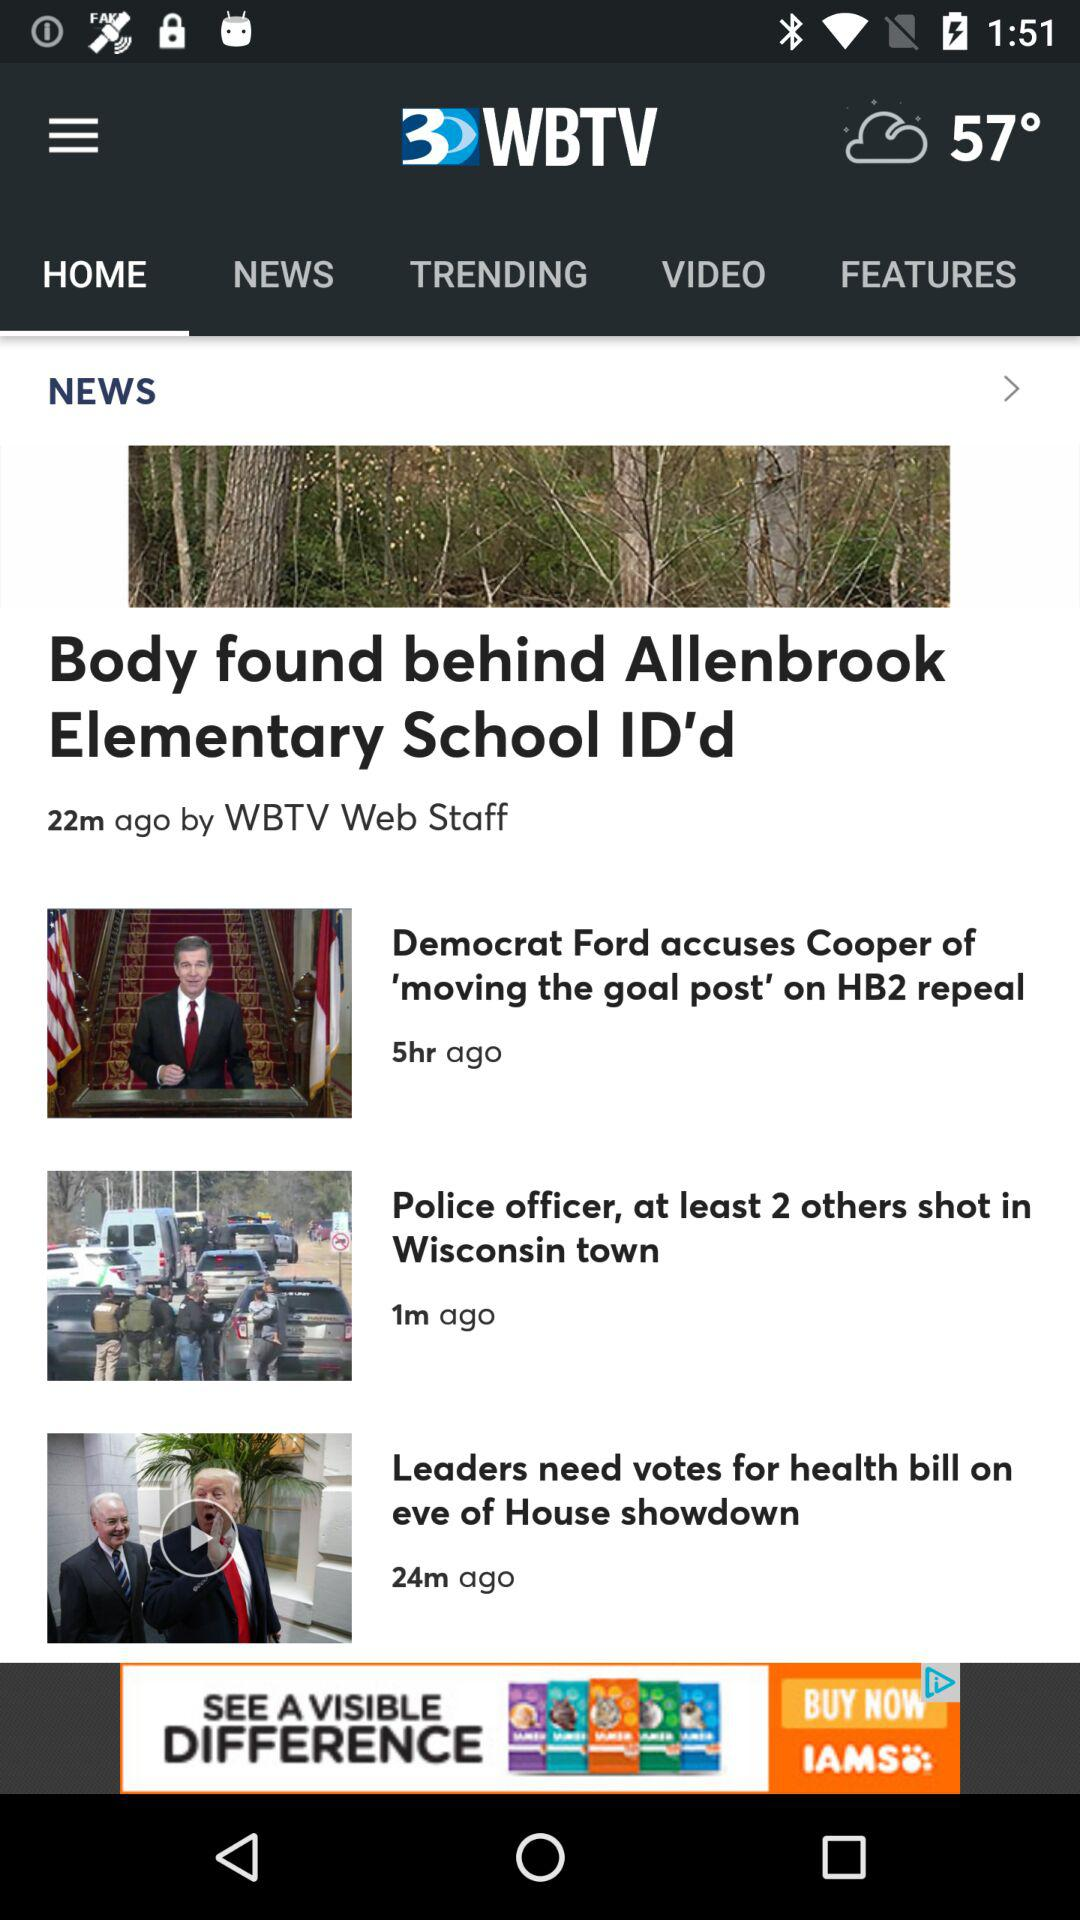What temperature is shown on the screen? The temperature shown on the screen is 57°. 